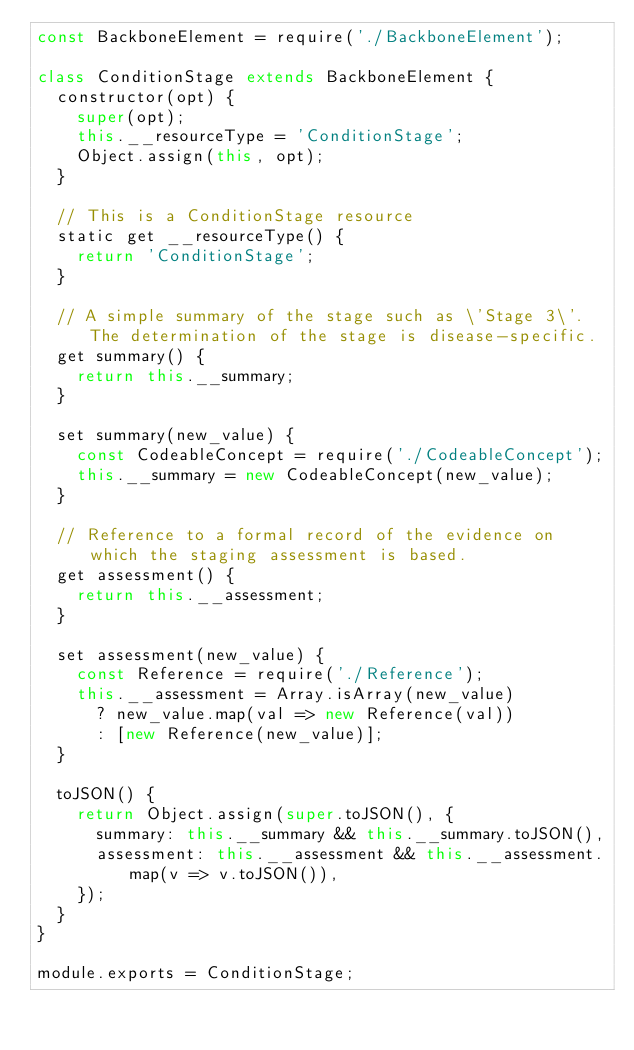<code> <loc_0><loc_0><loc_500><loc_500><_JavaScript_>const BackboneElement = require('./BackboneElement');

class ConditionStage extends BackboneElement {
	constructor(opt) {
		super(opt);
		this.__resourceType = 'ConditionStage';
		Object.assign(this, opt);
	}

	// This is a ConditionStage resource
	static get __resourceType() {
		return 'ConditionStage';
	}

	// A simple summary of the stage such as \'Stage 3\'. The determination of the stage is disease-specific.
	get summary() {
		return this.__summary;
	}

	set summary(new_value) {
		const CodeableConcept = require('./CodeableConcept');
		this.__summary = new CodeableConcept(new_value);
	}

	// Reference to a formal record of the evidence on which the staging assessment is based.
	get assessment() {
		return this.__assessment;
	}

	set assessment(new_value) {
		const Reference = require('./Reference');
		this.__assessment = Array.isArray(new_value)
			? new_value.map(val => new Reference(val))
			: [new Reference(new_value)];
	}

	toJSON() {
		return Object.assign(super.toJSON(), {
			summary: this.__summary && this.__summary.toJSON(),
			assessment: this.__assessment && this.__assessment.map(v => v.toJSON()),
		});
	}
}

module.exports = ConditionStage;
</code> 